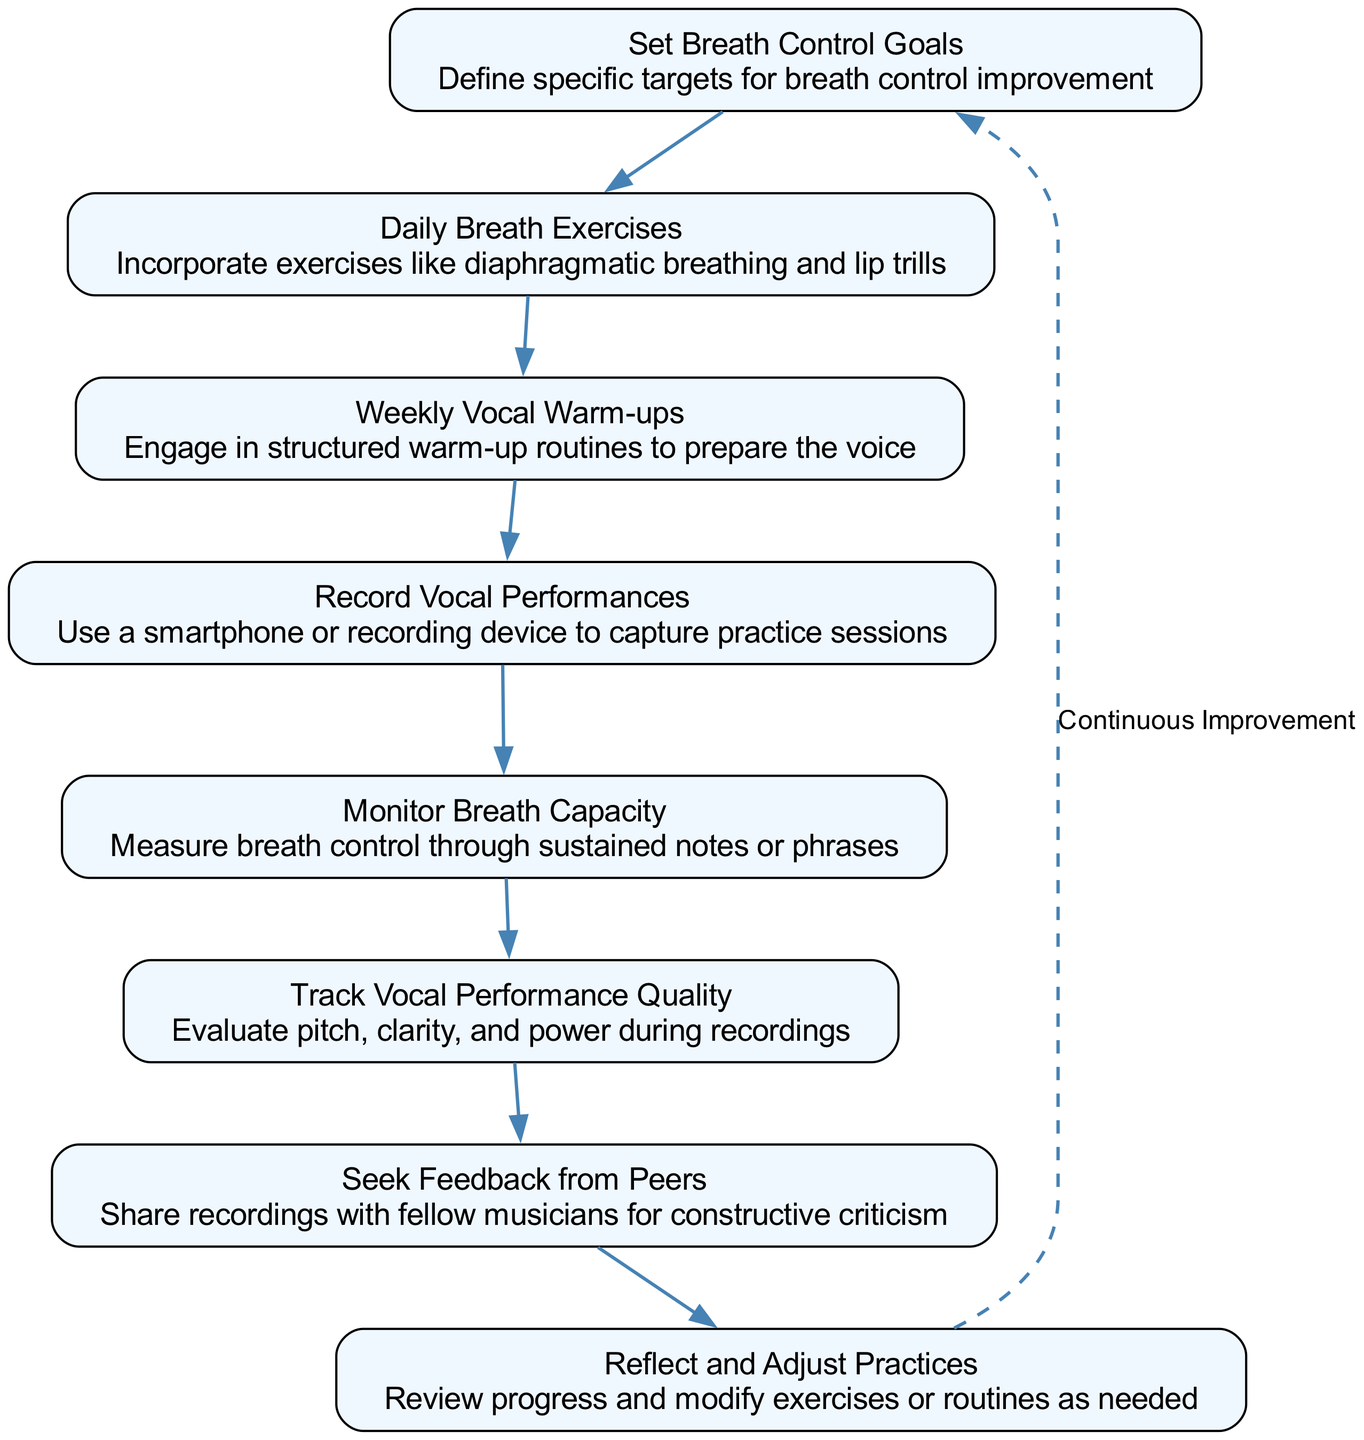What is the first node in the flow chart? The first node in the flow chart is labeled "Set Breath Control Goals." This is evident as it is the topmost element in the diagram, indicating the starting point of the process to track breath control and vocal performance.
Answer: Set Breath Control Goals How many elements are in the flow chart? By counting the nodes presented in the diagram, there are a total of eight distinct elements. Each of these represents a step in tracking breath control and vocal performance.
Answer: Eight What is the last step in the flow chart? The last step in the flow chart is "Reflect and Adjust Practices." It is the last element before cycling back to the first node in the process, indicating continuous improvement.
Answer: Reflect and Adjust Practices Which nodes directly follow the "Daily Breath Exercises"? The node that directly follows "Daily Breath Exercises" is "Weekly Vocal Warm-ups." This can be determined by observing the arrows that connect the nodes in the flowchart, showing the progression of steps.
Answer: Weekly Vocal Warm-ups What is indicated by the dashed line in the diagram? The dashed line in the diagram indicates a cycle from the last node back to the first node, illustrating the concept of "Continuous Improvement" in the process. This means the process is iterative and allows for repeated assessment and adjustments.
Answer: Continuous Improvement Which activity involves measuring breath control? The activity that involves measuring breath control is "Monitor Breath Capacity." It specifically focuses on assessing breath control through exercises like sustained notes or phrases, as indicated in the description.
Answer: Monitor Breath Capacity What type of feedback is encouraged according to the flow chart? The flow chart encourages "Seek Feedback from Peers," which emphasizes the importance of sharing recordings with fellow musicians to obtain constructive criticism for improvement.
Answer: Seek Feedback from Peers What do "Record Vocal Performances" and "Track Vocal Performance Quality" have in common? Both "Record Vocal Performances" and "Track Vocal Performance Quality" involve evaluating the sound produced during vocal practices. The first step captures audio, while the second step focuses on evaluating the captured audio for quality aspects like pitch and clarity.
Answer: Evaluation of vocal sound 